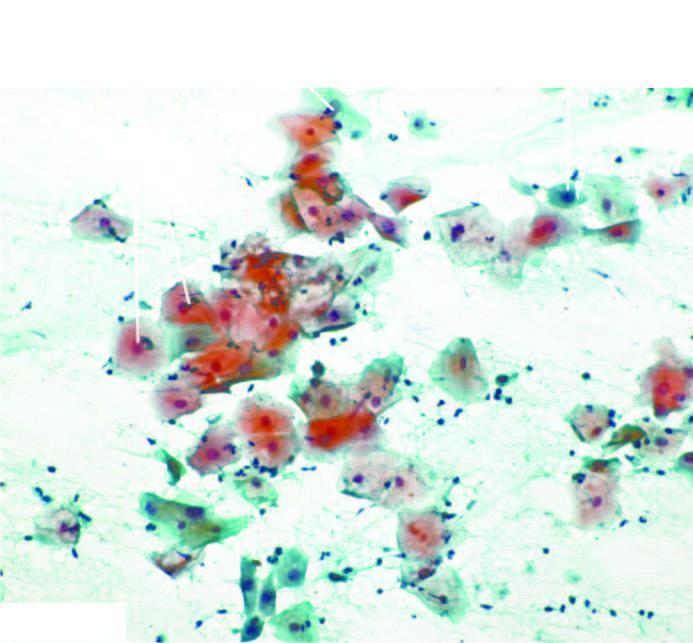re various types of epithelial cells seen in normal pap smear?
Answer the question using a single word or phrase. Yes 